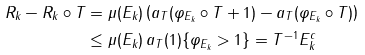Convert formula to latex. <formula><loc_0><loc_0><loc_500><loc_500>R _ { k } - R _ { k } \circ T & = \mu ( E _ { k } ) \left ( a _ { T } ( \varphi _ { E _ { k } } \circ T + 1 ) - a _ { T } ( \varphi _ { E _ { k } } \circ T ) \right ) \\ & \leq \mu ( E _ { k } ) \, a _ { T } ( 1 ) \{ \varphi _ { E _ { k } } > 1 \} = T ^ { - 1 } E _ { k } ^ { c }</formula> 